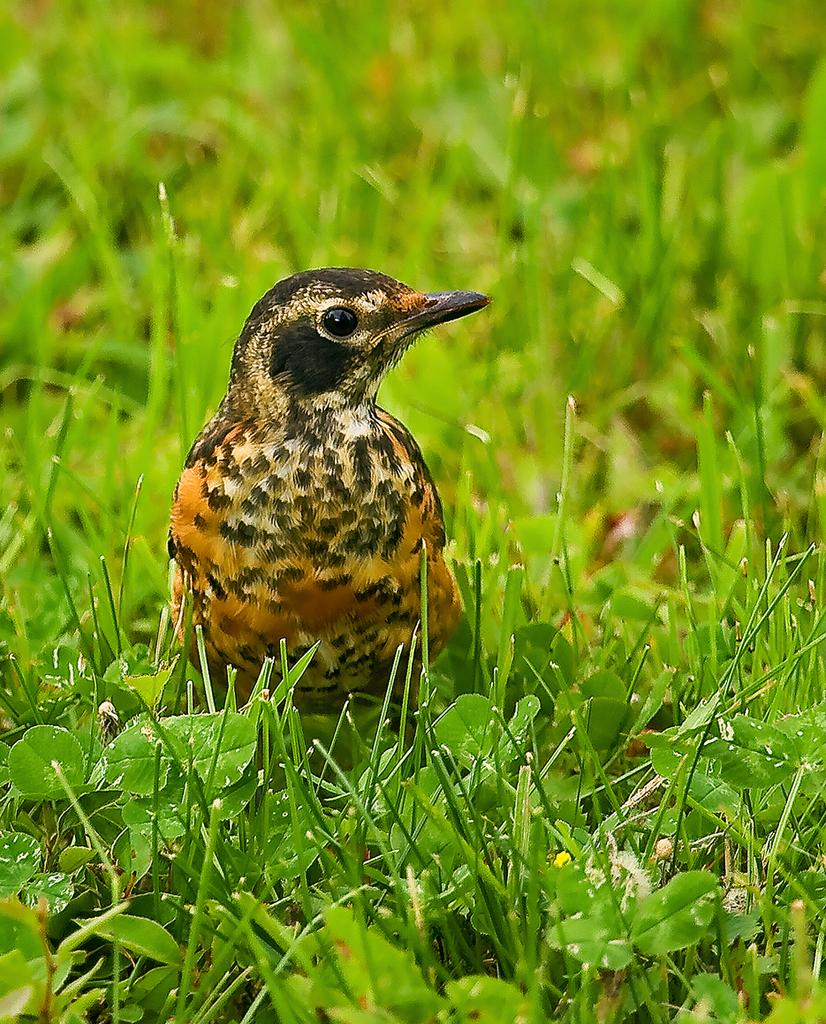What type of animal can be seen in the image? There is a bird in the image. Where is the bird located? The bird is sitting on the grass. What type of vegetation is visible in the image? There are green leaves visible in the image. What type of furniture can be seen in the image? There is no furniture present in the image; it features a bird sitting on the grass with green leaves visible. 